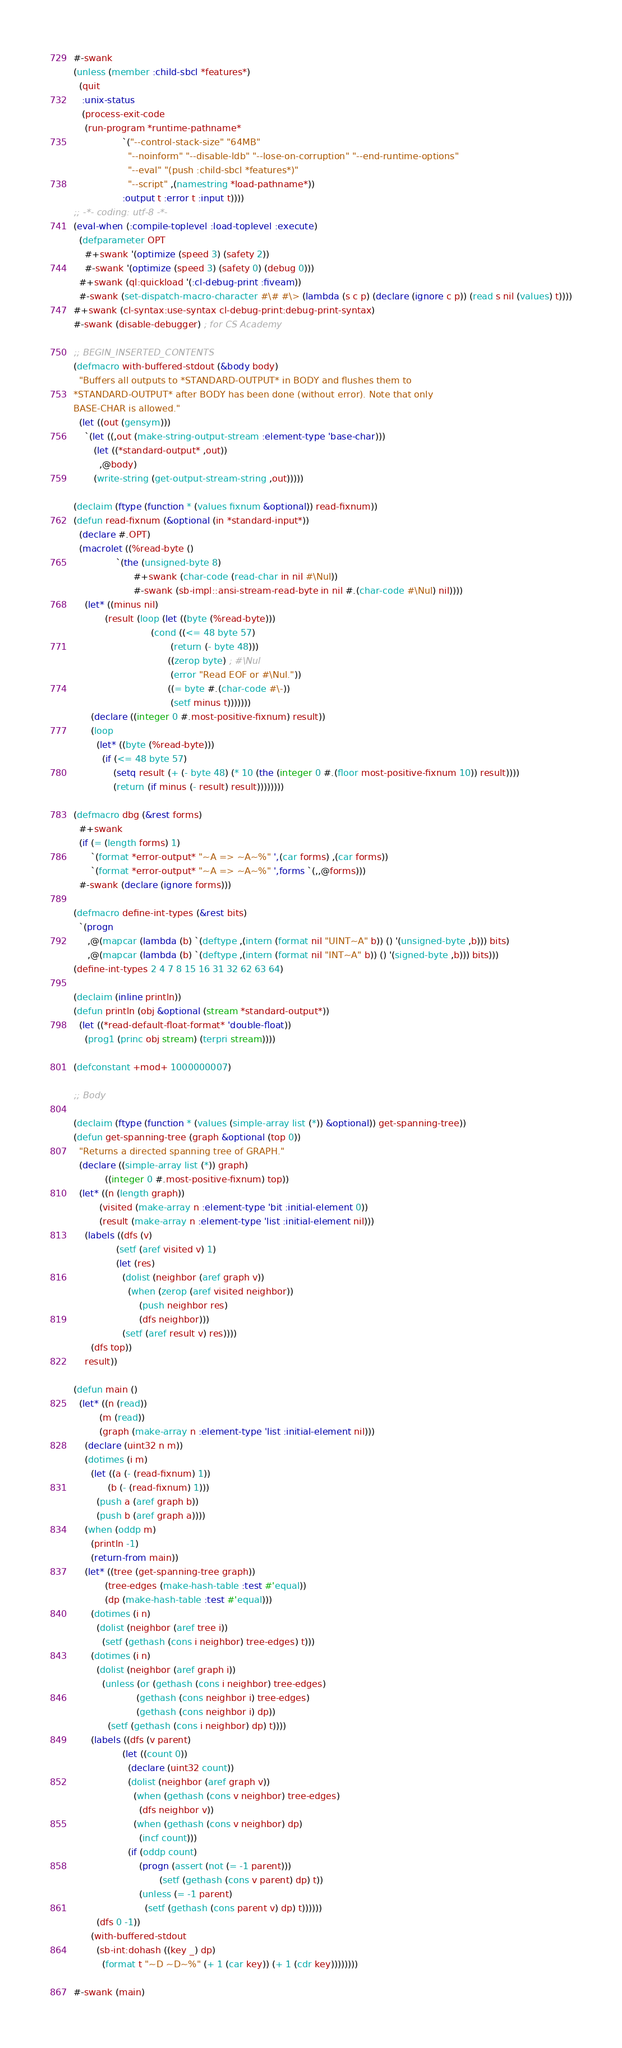Convert code to text. <code><loc_0><loc_0><loc_500><loc_500><_Lisp_>#-swank
(unless (member :child-sbcl *features*)
  (quit
   :unix-status
   (process-exit-code
    (run-program *runtime-pathname*
                 `("--control-stack-size" "64MB"
                   "--noinform" "--disable-ldb" "--lose-on-corruption" "--end-runtime-options"
                   "--eval" "(push :child-sbcl *features*)"
                   "--script" ,(namestring *load-pathname*))
                 :output t :error t :input t))))
;; -*- coding: utf-8 -*-
(eval-when (:compile-toplevel :load-toplevel :execute)
  (defparameter OPT
    #+swank '(optimize (speed 3) (safety 2))
    #-swank '(optimize (speed 3) (safety 0) (debug 0)))
  #+swank (ql:quickload '(:cl-debug-print :fiveam))
  #-swank (set-dispatch-macro-character #\# #\> (lambda (s c p) (declare (ignore c p)) (read s nil (values) t))))
#+swank (cl-syntax:use-syntax cl-debug-print:debug-print-syntax)
#-swank (disable-debugger) ; for CS Academy

;; BEGIN_INSERTED_CONTENTS
(defmacro with-buffered-stdout (&body body)
  "Buffers all outputs to *STANDARD-OUTPUT* in BODY and flushes them to
*STANDARD-OUTPUT* after BODY has been done (without error). Note that only
BASE-CHAR is allowed."
  (let ((out (gensym)))
    `(let ((,out (make-string-output-stream :element-type 'base-char)))
       (let ((*standard-output* ,out))
         ,@body)
       (write-string (get-output-stream-string ,out)))))

(declaim (ftype (function * (values fixnum &optional)) read-fixnum))
(defun read-fixnum (&optional (in *standard-input*))
  (declare #.OPT)
  (macrolet ((%read-byte ()
               `(the (unsigned-byte 8)
                     #+swank (char-code (read-char in nil #\Nul))
                     #-swank (sb-impl::ansi-stream-read-byte in nil #.(char-code #\Nul) nil))))
    (let* ((minus nil)
           (result (loop (let ((byte (%read-byte)))
                           (cond ((<= 48 byte 57)
                                  (return (- byte 48)))
                                 ((zerop byte) ; #\Nul
                                  (error "Read EOF or #\Nul."))
                                 ((= byte #.(char-code #\-))
                                  (setf minus t)))))))
      (declare ((integer 0 #.most-positive-fixnum) result))
      (loop
        (let* ((byte (%read-byte)))
          (if (<= 48 byte 57)
              (setq result (+ (- byte 48) (* 10 (the (integer 0 #.(floor most-positive-fixnum 10)) result))))
              (return (if minus (- result) result))))))))

(defmacro dbg (&rest forms)
  #+swank
  (if (= (length forms) 1)
      `(format *error-output* "~A => ~A~%" ',(car forms) ,(car forms))
      `(format *error-output* "~A => ~A~%" ',forms `(,,@forms)))
  #-swank (declare (ignore forms)))

(defmacro define-int-types (&rest bits)
  `(progn
     ,@(mapcar (lambda (b) `(deftype ,(intern (format nil "UINT~A" b)) () '(unsigned-byte ,b))) bits)
     ,@(mapcar (lambda (b) `(deftype ,(intern (format nil "INT~A" b)) () '(signed-byte ,b))) bits)))
(define-int-types 2 4 7 8 15 16 31 32 62 63 64)

(declaim (inline println))
(defun println (obj &optional (stream *standard-output*))
  (let ((*read-default-float-format* 'double-float))
    (prog1 (princ obj stream) (terpri stream))))

(defconstant +mod+ 1000000007)

;; Body

(declaim (ftype (function * (values (simple-array list (*)) &optional)) get-spanning-tree))
(defun get-spanning-tree (graph &optional (top 0))
  "Returns a directed spanning tree of GRAPH."
  (declare ((simple-array list (*)) graph)
           ((integer 0 #.most-positive-fixnum) top))
  (let* ((n (length graph))
         (visited (make-array n :element-type 'bit :initial-element 0))
         (result (make-array n :element-type 'list :initial-element nil)))
    (labels ((dfs (v)
               (setf (aref visited v) 1)
               (let (res)
                 (dolist (neighbor (aref graph v))
                   (when (zerop (aref visited neighbor))
                       (push neighbor res)
                       (dfs neighbor)))
                 (setf (aref result v) res))))
      (dfs top))
    result))

(defun main ()
  (let* ((n (read))
         (m (read))
         (graph (make-array n :element-type 'list :initial-element nil)))
    (declare (uint32 n m))
    (dotimes (i m)
      (let ((a (- (read-fixnum) 1))
            (b (- (read-fixnum) 1)))
        (push a (aref graph b))
        (push b (aref graph a))))
    (when (oddp m)
      (println -1)
      (return-from main))
    (let* ((tree (get-spanning-tree graph))
           (tree-edges (make-hash-table :test #'equal))
           (dp (make-hash-table :test #'equal)))
      (dotimes (i n)
        (dolist (neighbor (aref tree i))
          (setf (gethash (cons i neighbor) tree-edges) t)))
      (dotimes (i n)
        (dolist (neighbor (aref graph i))
          (unless (or (gethash (cons i neighbor) tree-edges)
                      (gethash (cons neighbor i) tree-edges)
                      (gethash (cons neighbor i) dp))
            (setf (gethash (cons i neighbor) dp) t))))
      (labels ((dfs (v parent)
                 (let ((count 0))
                   (declare (uint32 count))
                   (dolist (neighbor (aref graph v))
                     (when (gethash (cons v neighbor) tree-edges)
                       (dfs neighbor v))
                     (when (gethash (cons v neighbor) dp)
                       (incf count)))
                   (if (oddp count)
                       (progn (assert (not (= -1 parent)))
                              (setf (gethash (cons v parent) dp) t))
                       (unless (= -1 parent)
                         (setf (gethash (cons parent v) dp) t))))))
        (dfs 0 -1))
      (with-buffered-stdout
        (sb-int:dohash ((key _) dp)
          (format t "~D ~D~%" (+ 1 (car key)) (+ 1 (cdr key))))))))

#-swank (main)
</code> 